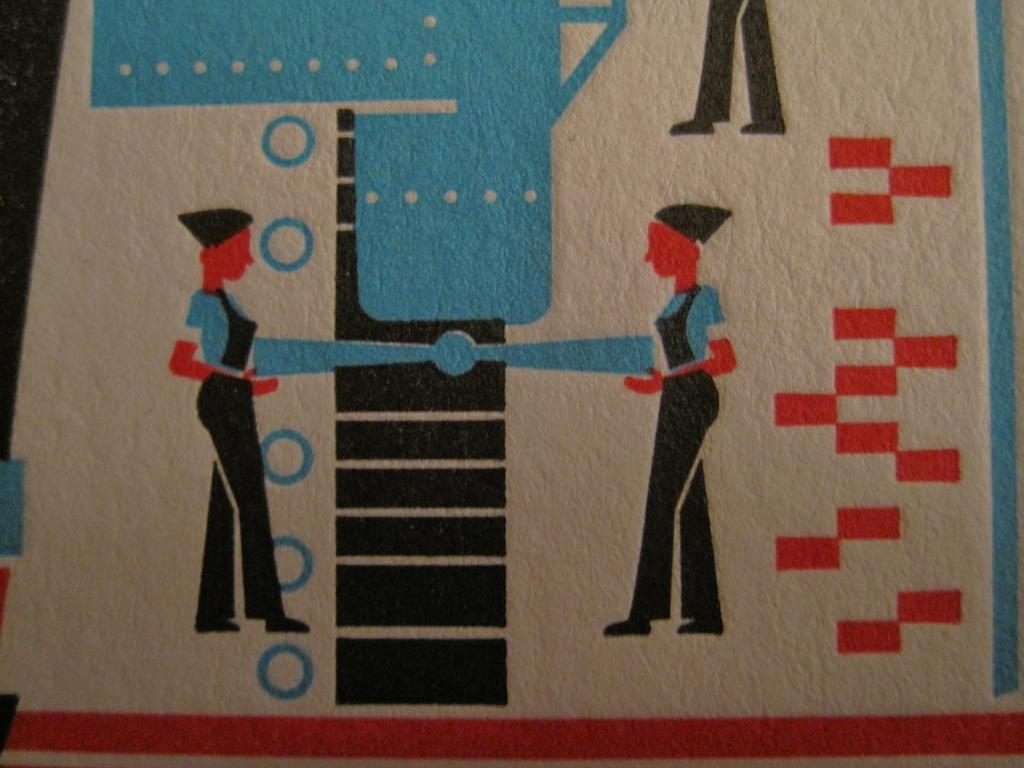How many cartoon persons are in the image? There are two cartoon persons in the image. What colors are used in the image? The image is in white, blue, orange, and black colors. Do the cartoon persons have any brothers in the image? There is no information about brothers in the image, as it only features two cartoon persons. What type of bucket can be seen in the image? There is no bucket present in the image. 